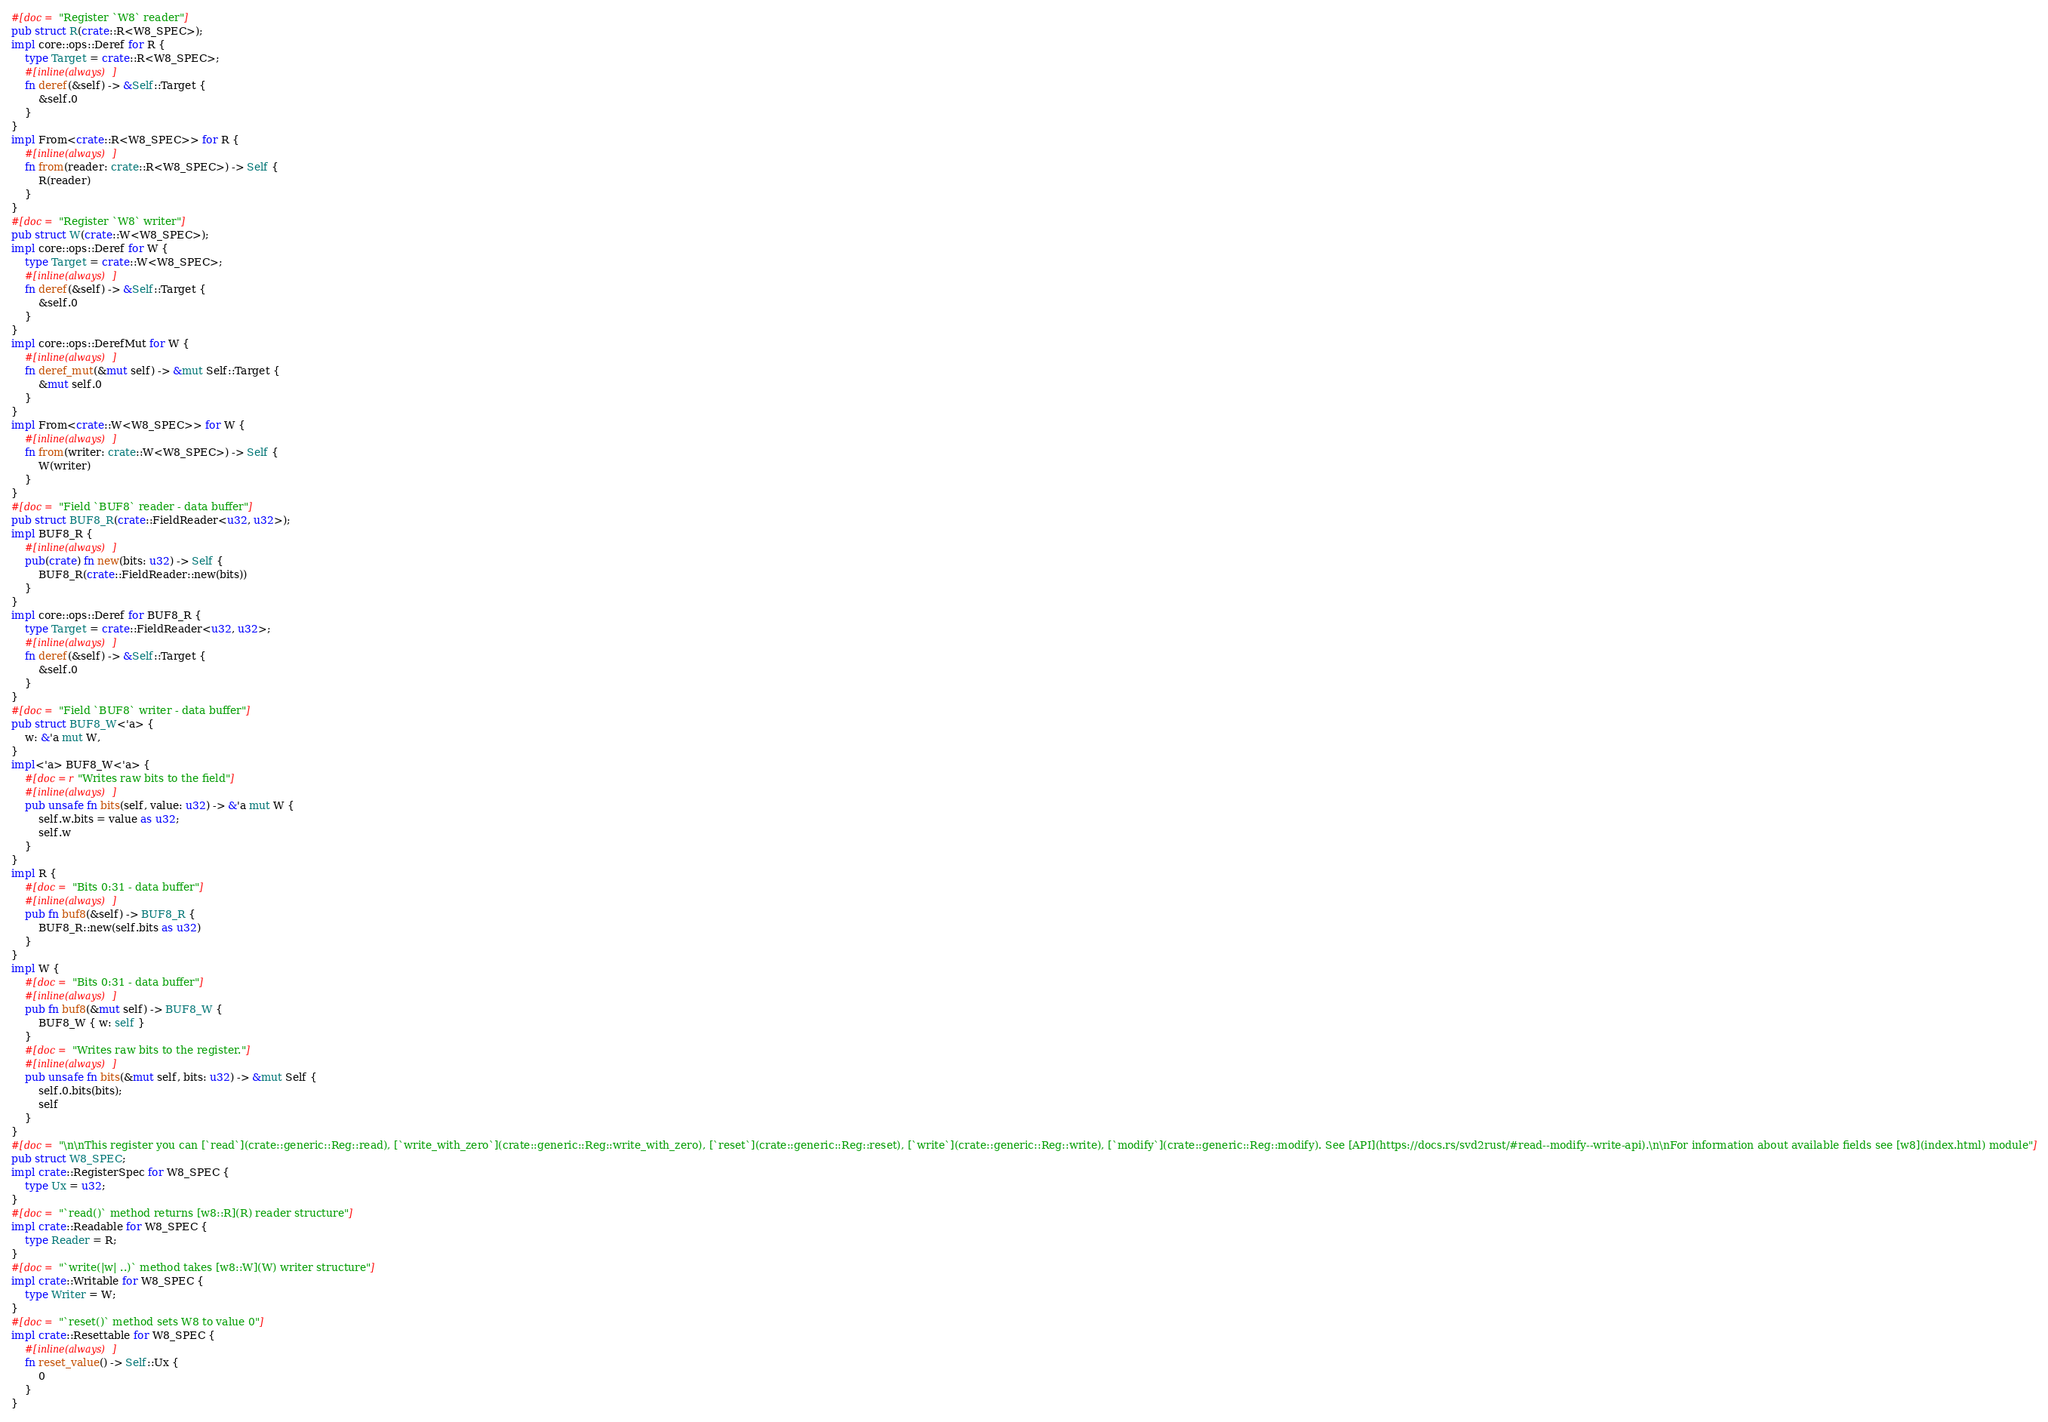Convert code to text. <code><loc_0><loc_0><loc_500><loc_500><_Rust_>#[doc = "Register `W8` reader"]
pub struct R(crate::R<W8_SPEC>);
impl core::ops::Deref for R {
    type Target = crate::R<W8_SPEC>;
    #[inline(always)]
    fn deref(&self) -> &Self::Target {
        &self.0
    }
}
impl From<crate::R<W8_SPEC>> for R {
    #[inline(always)]
    fn from(reader: crate::R<W8_SPEC>) -> Self {
        R(reader)
    }
}
#[doc = "Register `W8` writer"]
pub struct W(crate::W<W8_SPEC>);
impl core::ops::Deref for W {
    type Target = crate::W<W8_SPEC>;
    #[inline(always)]
    fn deref(&self) -> &Self::Target {
        &self.0
    }
}
impl core::ops::DerefMut for W {
    #[inline(always)]
    fn deref_mut(&mut self) -> &mut Self::Target {
        &mut self.0
    }
}
impl From<crate::W<W8_SPEC>> for W {
    #[inline(always)]
    fn from(writer: crate::W<W8_SPEC>) -> Self {
        W(writer)
    }
}
#[doc = "Field `BUF8` reader - data buffer"]
pub struct BUF8_R(crate::FieldReader<u32, u32>);
impl BUF8_R {
    #[inline(always)]
    pub(crate) fn new(bits: u32) -> Self {
        BUF8_R(crate::FieldReader::new(bits))
    }
}
impl core::ops::Deref for BUF8_R {
    type Target = crate::FieldReader<u32, u32>;
    #[inline(always)]
    fn deref(&self) -> &Self::Target {
        &self.0
    }
}
#[doc = "Field `BUF8` writer - data buffer"]
pub struct BUF8_W<'a> {
    w: &'a mut W,
}
impl<'a> BUF8_W<'a> {
    #[doc = r"Writes raw bits to the field"]
    #[inline(always)]
    pub unsafe fn bits(self, value: u32) -> &'a mut W {
        self.w.bits = value as u32;
        self.w
    }
}
impl R {
    #[doc = "Bits 0:31 - data buffer"]
    #[inline(always)]
    pub fn buf8(&self) -> BUF8_R {
        BUF8_R::new(self.bits as u32)
    }
}
impl W {
    #[doc = "Bits 0:31 - data buffer"]
    #[inline(always)]
    pub fn buf8(&mut self) -> BUF8_W {
        BUF8_W { w: self }
    }
    #[doc = "Writes raw bits to the register."]
    #[inline(always)]
    pub unsafe fn bits(&mut self, bits: u32) -> &mut Self {
        self.0.bits(bits);
        self
    }
}
#[doc = "\n\nThis register you can [`read`](crate::generic::Reg::read), [`write_with_zero`](crate::generic::Reg::write_with_zero), [`reset`](crate::generic::Reg::reset), [`write`](crate::generic::Reg::write), [`modify`](crate::generic::Reg::modify). See [API](https://docs.rs/svd2rust/#read--modify--write-api).\n\nFor information about available fields see [w8](index.html) module"]
pub struct W8_SPEC;
impl crate::RegisterSpec for W8_SPEC {
    type Ux = u32;
}
#[doc = "`read()` method returns [w8::R](R) reader structure"]
impl crate::Readable for W8_SPEC {
    type Reader = R;
}
#[doc = "`write(|w| ..)` method takes [w8::W](W) writer structure"]
impl crate::Writable for W8_SPEC {
    type Writer = W;
}
#[doc = "`reset()` method sets W8 to value 0"]
impl crate::Resettable for W8_SPEC {
    #[inline(always)]
    fn reset_value() -> Self::Ux {
        0
    }
}
</code> 